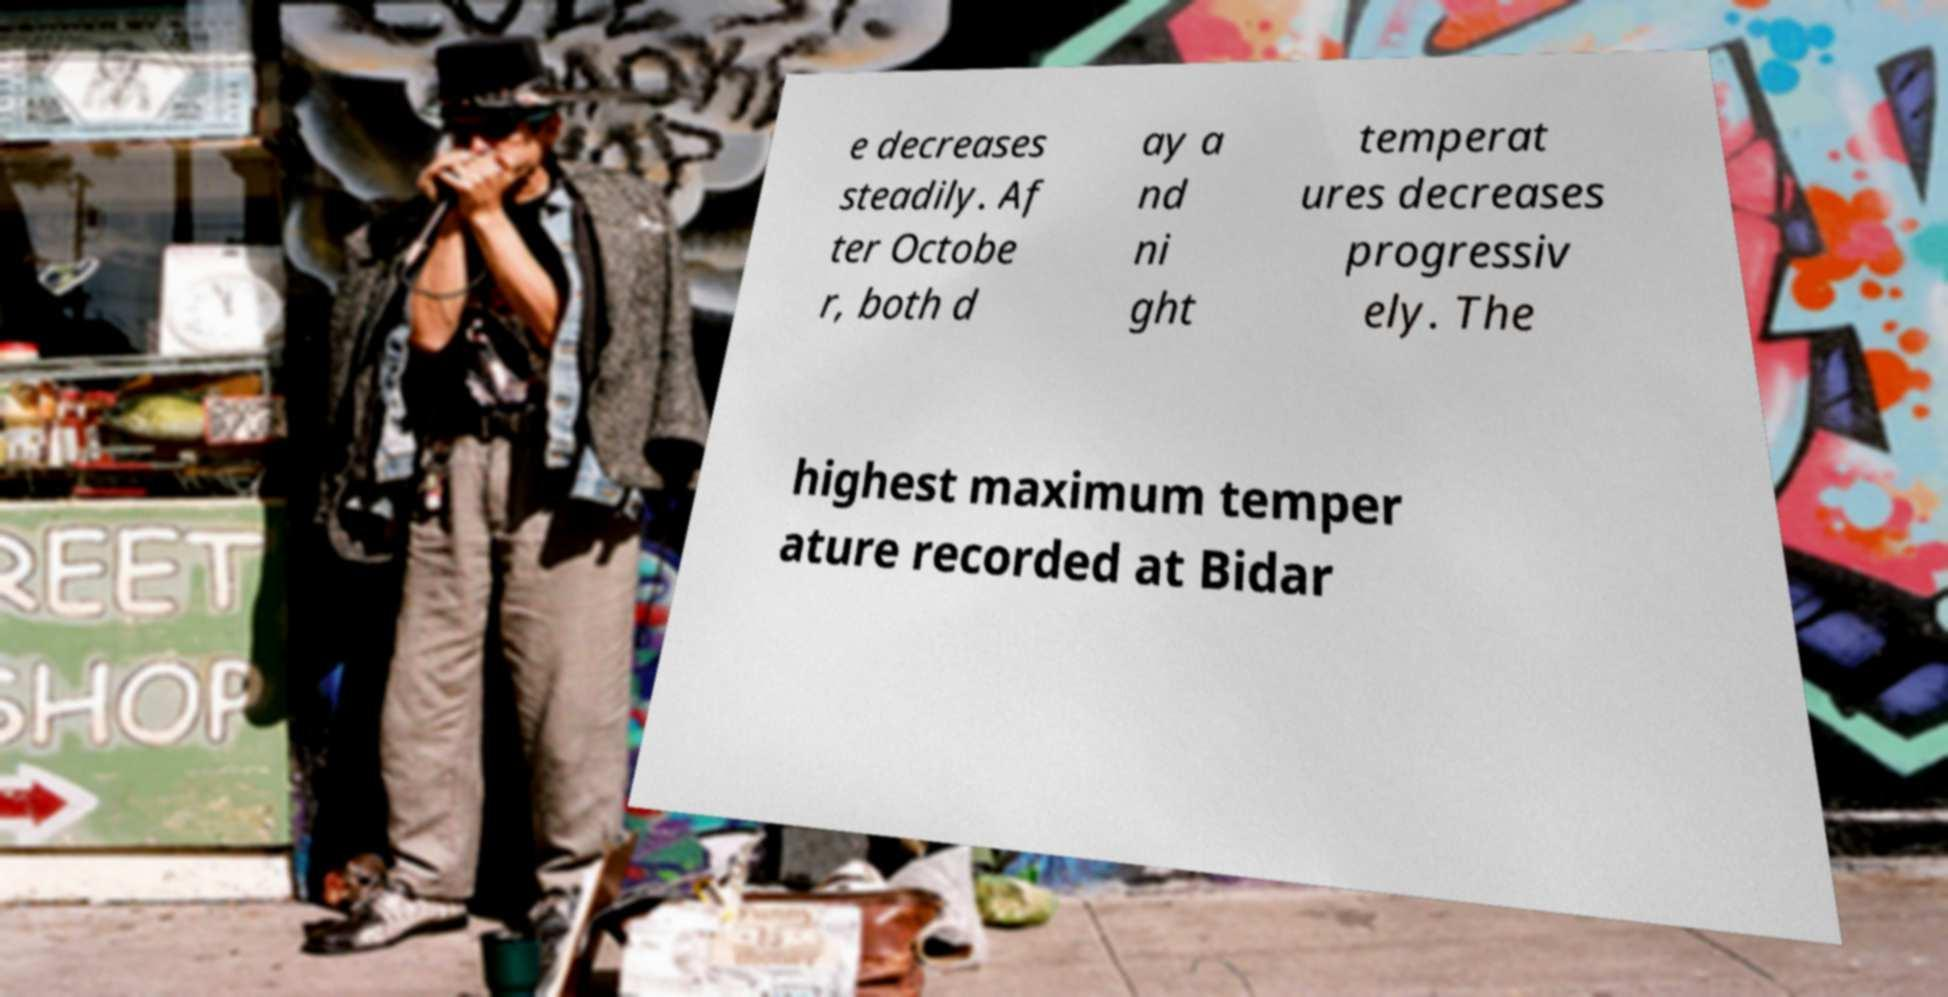Can you accurately transcribe the text from the provided image for me? e decreases steadily. Af ter Octobe r, both d ay a nd ni ght temperat ures decreases progressiv ely. The highest maximum temper ature recorded at Bidar 